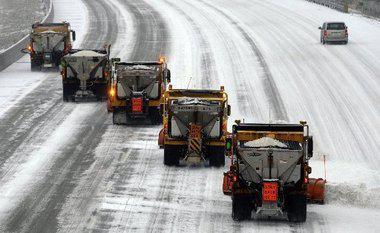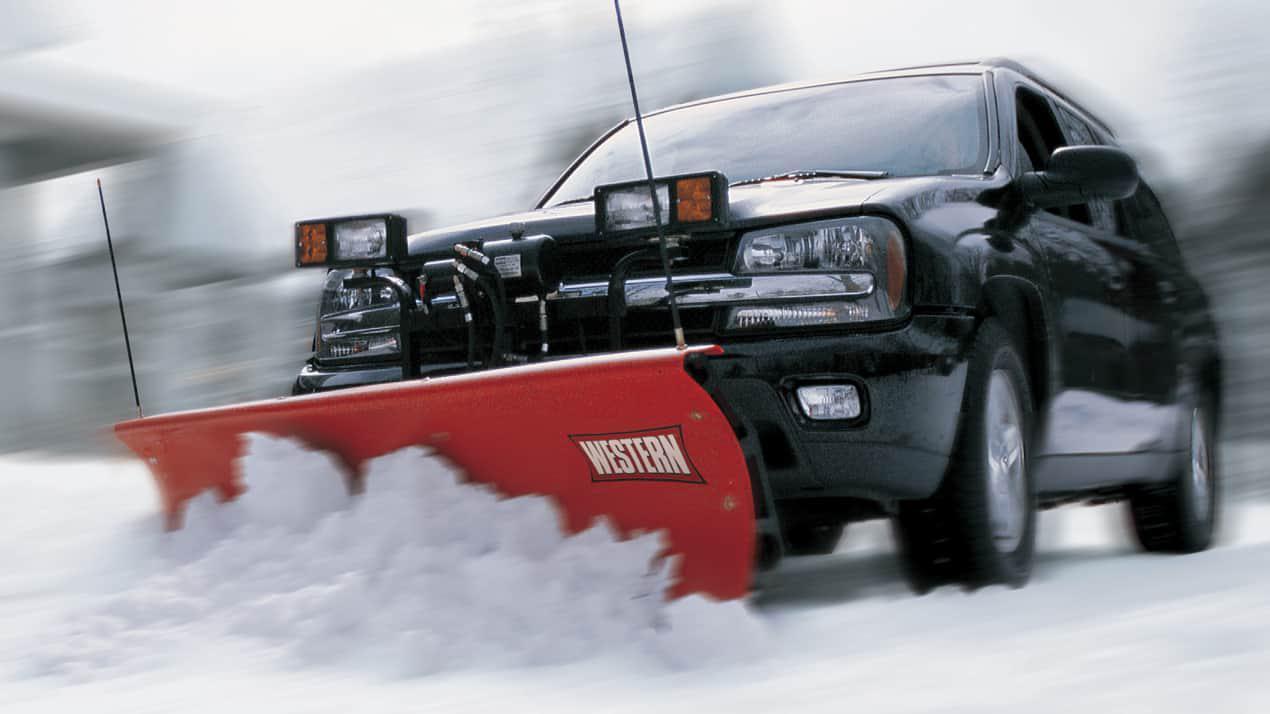The first image is the image on the left, the second image is the image on the right. For the images displayed, is the sentence "There are flags on the plow blade in the image on the left." factually correct? Answer yes or no. No. The first image is the image on the left, the second image is the image on the right. Assess this claim about the two images: "The left image shows exactly one commercial snowplow truck facing the camera.". Correct or not? Answer yes or no. No. 